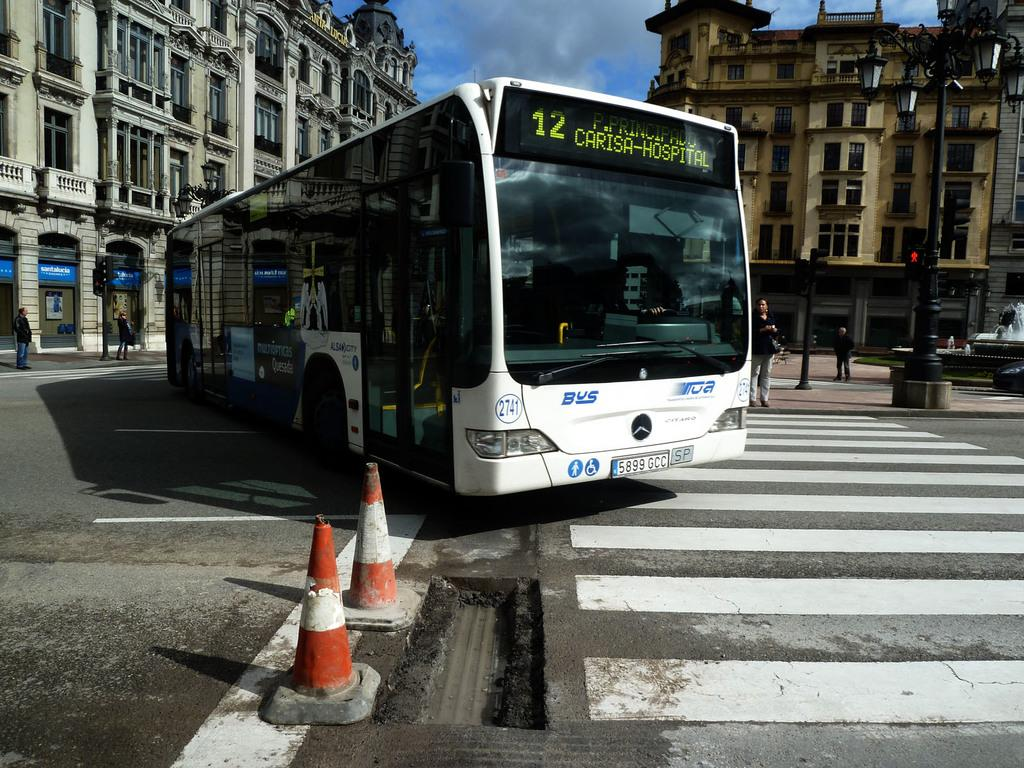<image>
Describe the image concisely. bus number 12 going to carisa-hospital on the street 